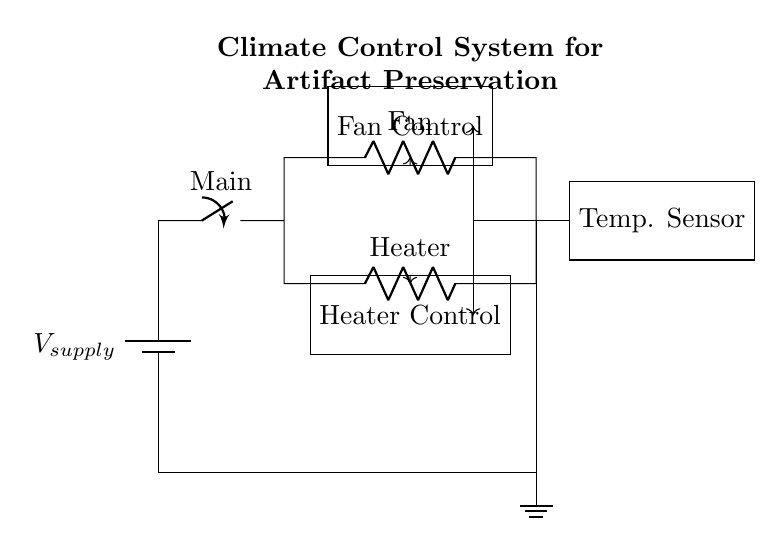What two components are in parallel in this circuit? The two components in parallel are the fan and heater. In a parallel circuit, components are connected along multiple paths, allowing current to flow through each component independently. Here, the fan and heater branches are shown to be connected side by side from the main switch.
Answer: fan and heater What does the fan control unit regulate? The fan control unit regulates the operation of the fan within the climate control system. The diagram indicates that the fan control receives signals from the temperature sensor, indicating its role in maintaining the temperature for artifact preservation.
Answer: fan Which component is powered by the voltage supply? The voltage supply powers the entire circuit, including both the fan and heater circuits. The circuit initially shows a connection going from the battery (voltage supply) to the main switch, which subsequently connects to the branches for the fan and heater.
Answer: entire circuit How many control units are depicted in the diagram? There are two control units depicted in the diagram: one for the fan and one for the heater. Each control unit is drawn as a rectangular box, with arrows showing that they receive inputs from the temperature sensor.
Answer: two What type of circuit configuration is used for the fan and heater? The fan and heater are connected in a parallel configuration. In a parallel circuit, each component has its own direct path to the power source, which is evident in the diagram where both components are on separate branches leading back to the same supply voltage.
Answer: parallel What role does the temperature sensor play in this system? The temperature sensor monitors the environmental conditions and sends relevant data to the control units for both fan and heater. This feedback is crucial for adjusting the operation of these components to ensure optimal preservation for artifacts.
Answer: monitoring What would happen if one of the components fails in a parallel circuit? If one component fails in a parallel circuit, the other components continue to operate normally since they each have their own independent path. In this case, if the fan were to fail, the heater would still function as intended for artifact preservation, maintaining the necessary climate conditions.
Answer: other components operate 